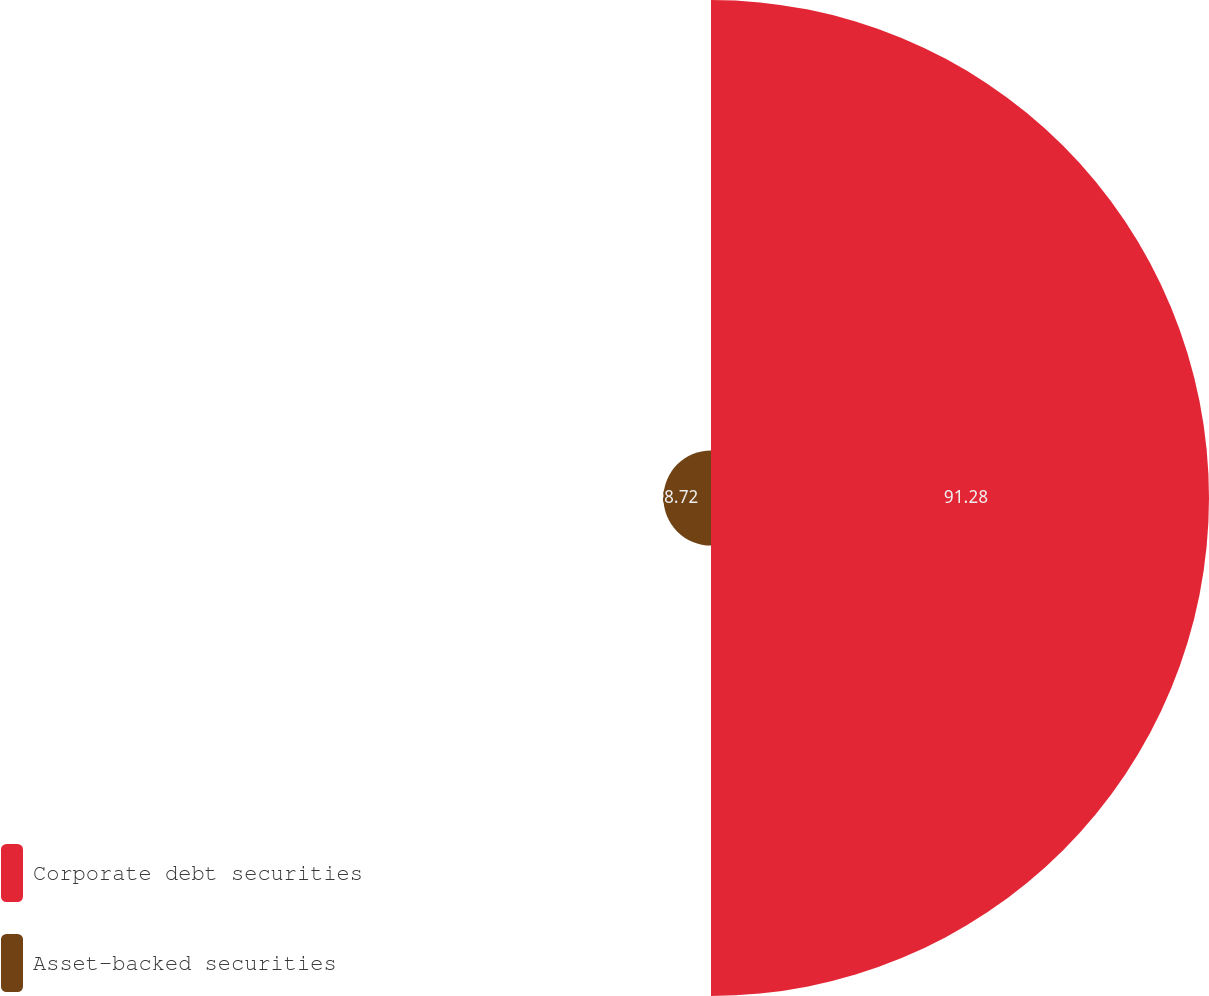Convert chart to OTSL. <chart><loc_0><loc_0><loc_500><loc_500><pie_chart><fcel>Corporate debt securities<fcel>Asset-backed securities<nl><fcel>91.28%<fcel>8.72%<nl></chart> 